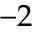<formula> <loc_0><loc_0><loc_500><loc_500>- 2</formula> 